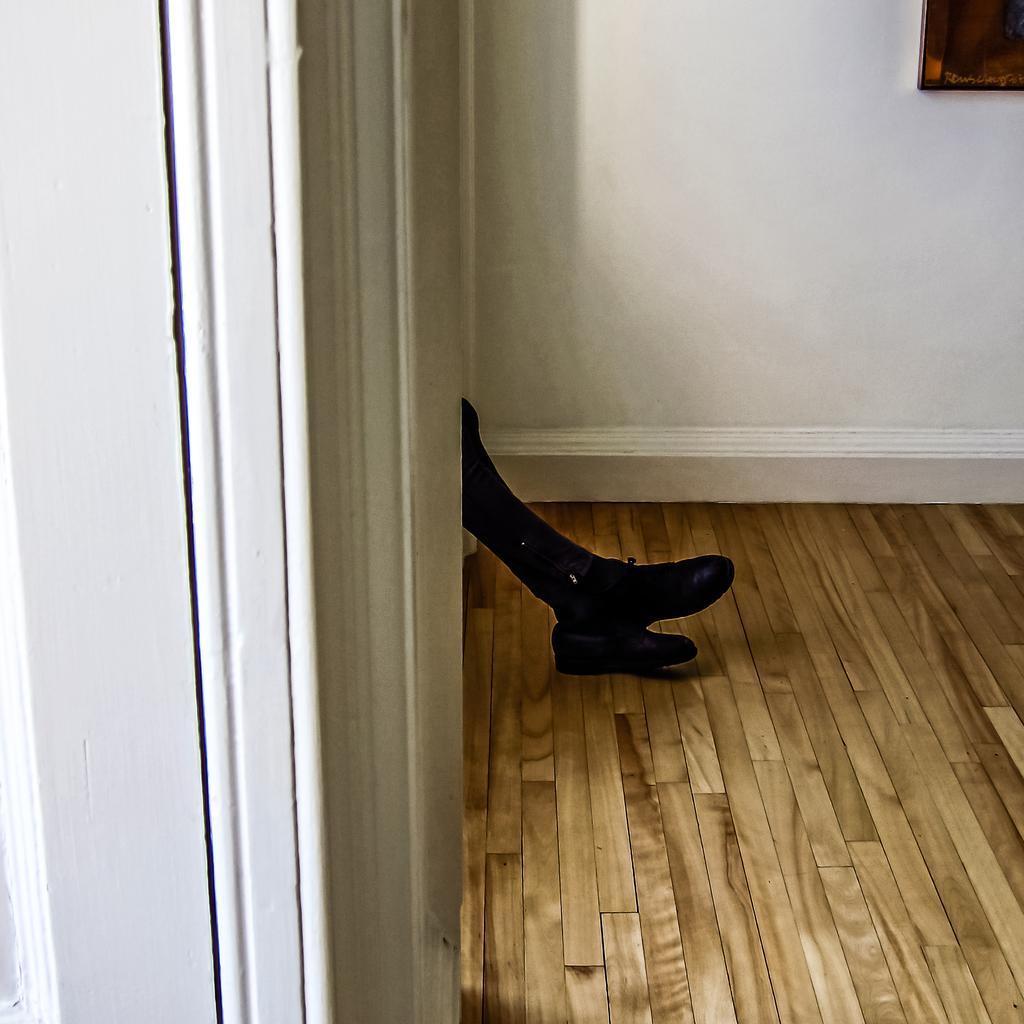Describe this image in one or two sentences. In this image we can see the legs of a person. At the bottom there is a wooden floor. In the background there is a frame hanging on the wall. 